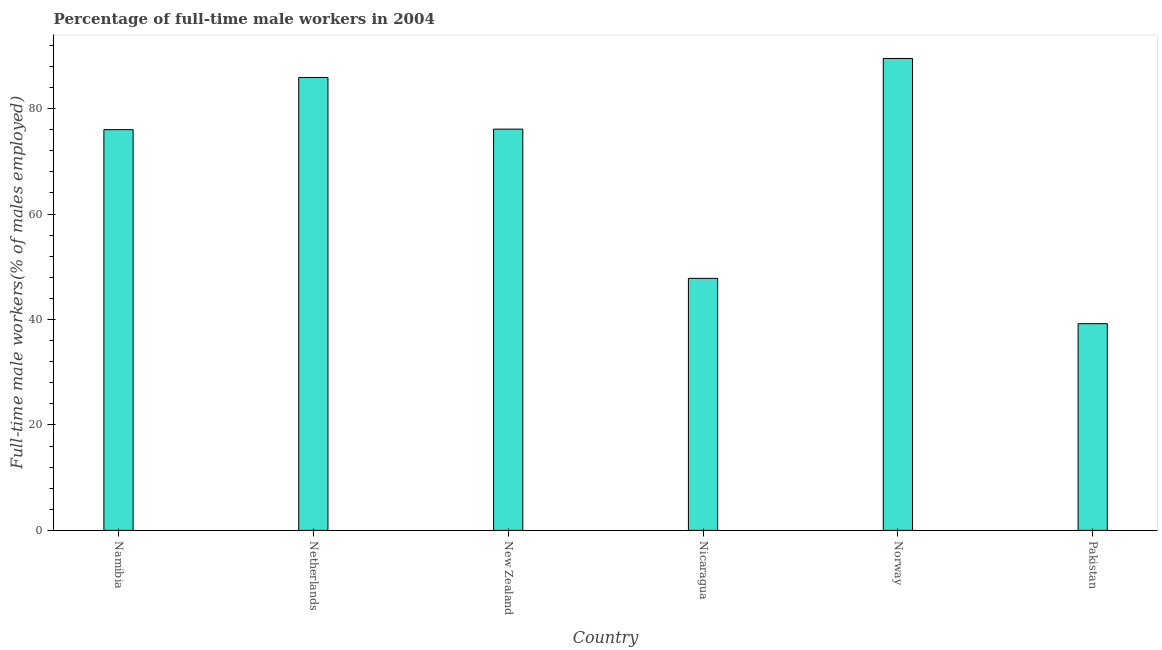Does the graph contain any zero values?
Your answer should be very brief. No. Does the graph contain grids?
Ensure brevity in your answer.  No. What is the title of the graph?
Offer a terse response. Percentage of full-time male workers in 2004. What is the label or title of the X-axis?
Offer a very short reply. Country. What is the label or title of the Y-axis?
Your answer should be compact. Full-time male workers(% of males employed). Across all countries, what is the maximum percentage of full-time male workers?
Ensure brevity in your answer.  89.5. Across all countries, what is the minimum percentage of full-time male workers?
Ensure brevity in your answer.  39.2. In which country was the percentage of full-time male workers minimum?
Your answer should be very brief. Pakistan. What is the sum of the percentage of full-time male workers?
Your answer should be very brief. 414.5. What is the difference between the percentage of full-time male workers in New Zealand and Pakistan?
Make the answer very short. 36.9. What is the average percentage of full-time male workers per country?
Make the answer very short. 69.08. What is the median percentage of full-time male workers?
Your answer should be very brief. 76.05. What is the ratio of the percentage of full-time male workers in Namibia to that in Norway?
Your response must be concise. 0.85. Is the difference between the percentage of full-time male workers in Namibia and Nicaragua greater than the difference between any two countries?
Provide a succinct answer. No. Is the sum of the percentage of full-time male workers in Namibia and Norway greater than the maximum percentage of full-time male workers across all countries?
Give a very brief answer. Yes. What is the difference between the highest and the lowest percentage of full-time male workers?
Your answer should be very brief. 50.3. In how many countries, is the percentage of full-time male workers greater than the average percentage of full-time male workers taken over all countries?
Keep it short and to the point. 4. Are all the bars in the graph horizontal?
Offer a terse response. No. How many countries are there in the graph?
Your answer should be compact. 6. What is the Full-time male workers(% of males employed) of Namibia?
Provide a short and direct response. 76. What is the Full-time male workers(% of males employed) in Netherlands?
Provide a succinct answer. 85.9. What is the Full-time male workers(% of males employed) in New Zealand?
Provide a short and direct response. 76.1. What is the Full-time male workers(% of males employed) of Nicaragua?
Provide a short and direct response. 47.8. What is the Full-time male workers(% of males employed) of Norway?
Make the answer very short. 89.5. What is the Full-time male workers(% of males employed) in Pakistan?
Give a very brief answer. 39.2. What is the difference between the Full-time male workers(% of males employed) in Namibia and New Zealand?
Your answer should be compact. -0.1. What is the difference between the Full-time male workers(% of males employed) in Namibia and Nicaragua?
Provide a short and direct response. 28.2. What is the difference between the Full-time male workers(% of males employed) in Namibia and Norway?
Keep it short and to the point. -13.5. What is the difference between the Full-time male workers(% of males employed) in Namibia and Pakistan?
Offer a very short reply. 36.8. What is the difference between the Full-time male workers(% of males employed) in Netherlands and New Zealand?
Your answer should be very brief. 9.8. What is the difference between the Full-time male workers(% of males employed) in Netherlands and Nicaragua?
Your response must be concise. 38.1. What is the difference between the Full-time male workers(% of males employed) in Netherlands and Pakistan?
Keep it short and to the point. 46.7. What is the difference between the Full-time male workers(% of males employed) in New Zealand and Nicaragua?
Ensure brevity in your answer.  28.3. What is the difference between the Full-time male workers(% of males employed) in New Zealand and Pakistan?
Make the answer very short. 36.9. What is the difference between the Full-time male workers(% of males employed) in Nicaragua and Norway?
Provide a succinct answer. -41.7. What is the difference between the Full-time male workers(% of males employed) in Nicaragua and Pakistan?
Offer a terse response. 8.6. What is the difference between the Full-time male workers(% of males employed) in Norway and Pakistan?
Provide a short and direct response. 50.3. What is the ratio of the Full-time male workers(% of males employed) in Namibia to that in Netherlands?
Ensure brevity in your answer.  0.89. What is the ratio of the Full-time male workers(% of males employed) in Namibia to that in New Zealand?
Your answer should be very brief. 1. What is the ratio of the Full-time male workers(% of males employed) in Namibia to that in Nicaragua?
Your response must be concise. 1.59. What is the ratio of the Full-time male workers(% of males employed) in Namibia to that in Norway?
Your answer should be compact. 0.85. What is the ratio of the Full-time male workers(% of males employed) in Namibia to that in Pakistan?
Make the answer very short. 1.94. What is the ratio of the Full-time male workers(% of males employed) in Netherlands to that in New Zealand?
Offer a very short reply. 1.13. What is the ratio of the Full-time male workers(% of males employed) in Netherlands to that in Nicaragua?
Give a very brief answer. 1.8. What is the ratio of the Full-time male workers(% of males employed) in Netherlands to that in Pakistan?
Provide a succinct answer. 2.19. What is the ratio of the Full-time male workers(% of males employed) in New Zealand to that in Nicaragua?
Ensure brevity in your answer.  1.59. What is the ratio of the Full-time male workers(% of males employed) in New Zealand to that in Norway?
Your response must be concise. 0.85. What is the ratio of the Full-time male workers(% of males employed) in New Zealand to that in Pakistan?
Make the answer very short. 1.94. What is the ratio of the Full-time male workers(% of males employed) in Nicaragua to that in Norway?
Ensure brevity in your answer.  0.53. What is the ratio of the Full-time male workers(% of males employed) in Nicaragua to that in Pakistan?
Offer a very short reply. 1.22. What is the ratio of the Full-time male workers(% of males employed) in Norway to that in Pakistan?
Ensure brevity in your answer.  2.28. 